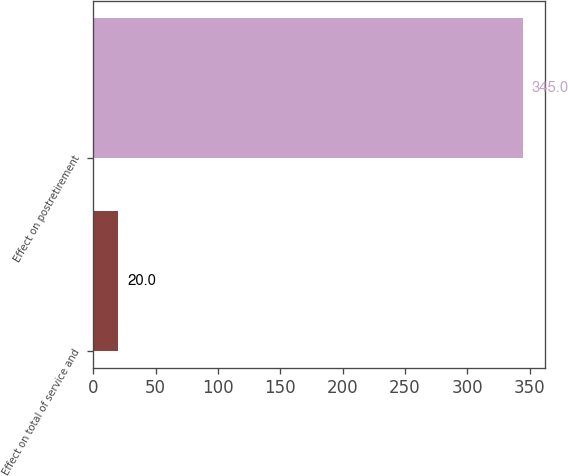Convert chart to OTSL. <chart><loc_0><loc_0><loc_500><loc_500><bar_chart><fcel>Effect on total of service and<fcel>Effect on postretirement<nl><fcel>20<fcel>345<nl></chart> 